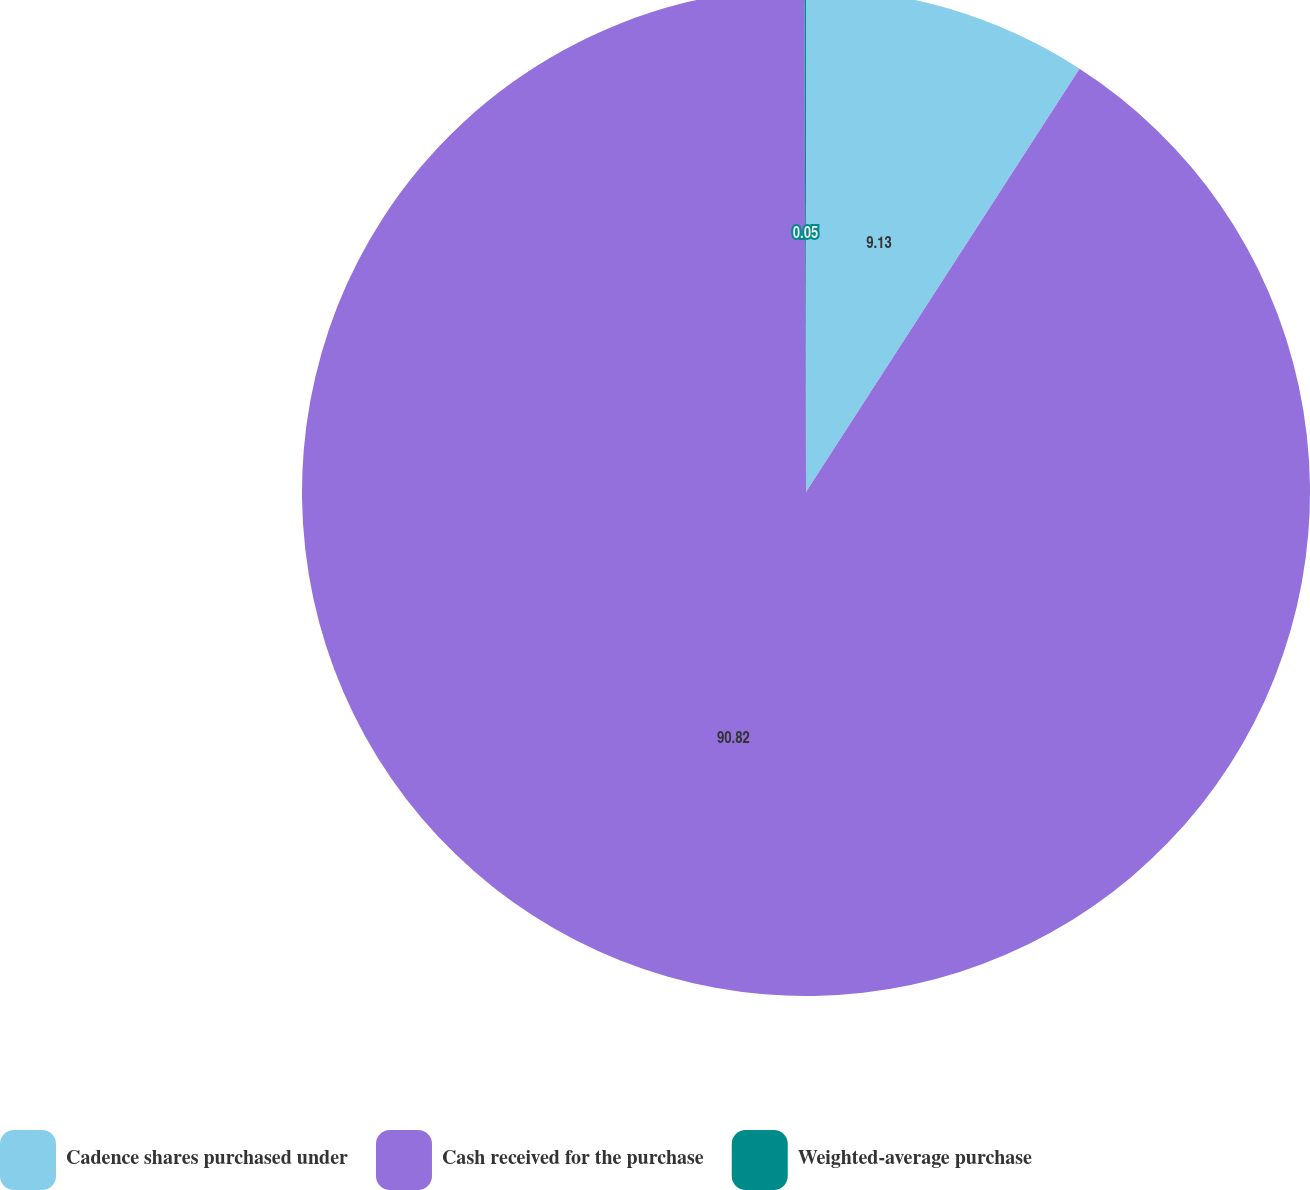Convert chart to OTSL. <chart><loc_0><loc_0><loc_500><loc_500><pie_chart><fcel>Cadence shares purchased under<fcel>Cash received for the purchase<fcel>Weighted-average purchase<nl><fcel>9.13%<fcel>90.82%<fcel>0.05%<nl></chart> 